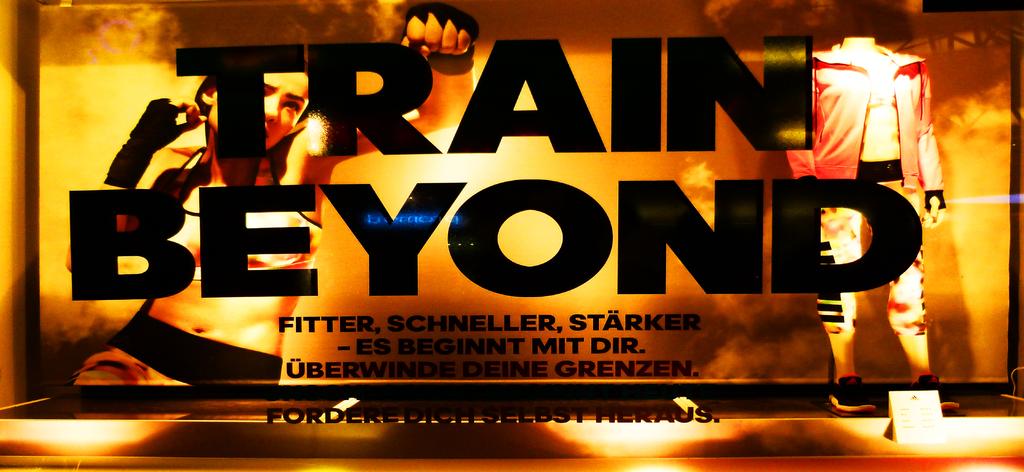What does the billboard advertise?
Your response must be concise. Train beyond. 